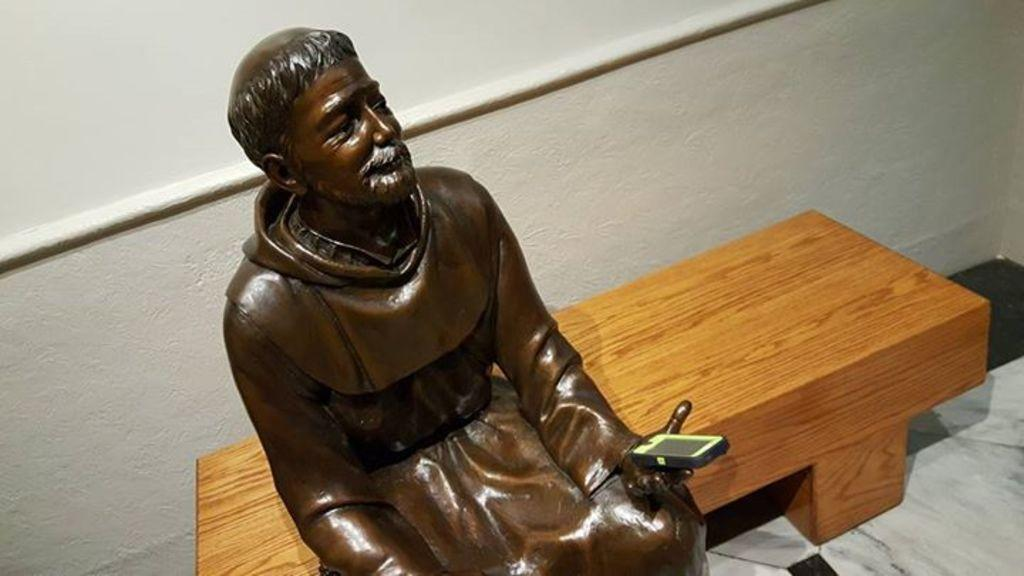What is the main subject of the image? There is a statue of a man in the image. What is the statue doing in the image? The man is sitting on a bench in the image. Where is the bench located in the image? The bench is on the left side of the image. What is the statue holding in its hand? The statue is holding a cell phone in its hand. What is the color of the statue? The color of the statue is brown. What type of balloon is the statue holding in the image? There is no balloon present in the image; the statue is holding a cell phone. What kind of operation is the statue performing on the writer in the image? There is no operation or writer depicted in the image; it features a statue of a man holding a cell phone. 